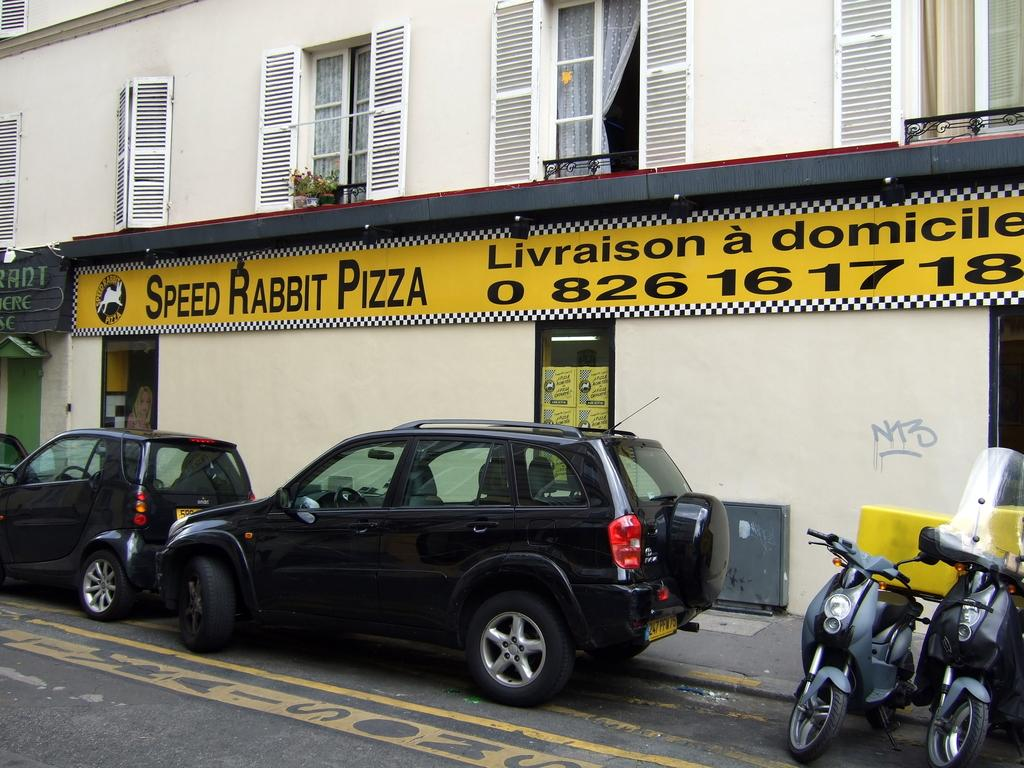What can be seen on the road in the image? There are vehicles parked on the road in the image. What else is visible in the image besides the parked vehicles? There is a building visible in the image. What book is the brother reading in the image? There is no book or brother present in the image; it only features parked vehicles and a building. 